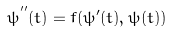Convert formula to latex. <formula><loc_0><loc_0><loc_500><loc_500>\psi ^ { ^ { \prime \prime } } ( t ) = f ( \psi ^ { \prime } ( t ) , \psi ( t ) )</formula> 